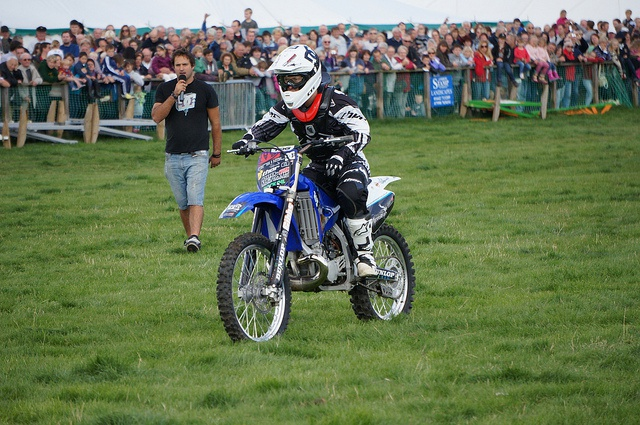Describe the objects in this image and their specific colors. I can see people in lightgray, black, gray, and darkgray tones, motorcycle in lightgray, black, gray, and darkgray tones, people in lightgray, black, gray, and darkgray tones, people in lightgray, black, darkgray, and gray tones, and people in lightgray, black, gray, and darkgray tones in this image. 